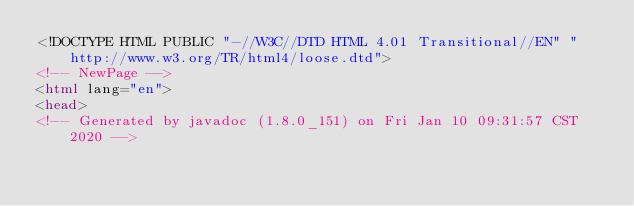<code> <loc_0><loc_0><loc_500><loc_500><_HTML_><!DOCTYPE HTML PUBLIC "-//W3C//DTD HTML 4.01 Transitional//EN" "http://www.w3.org/TR/html4/loose.dtd">
<!-- NewPage -->
<html lang="en">
<head>
<!-- Generated by javadoc (1.8.0_151) on Fri Jan 10 09:31:57 CST 2020 --></code> 